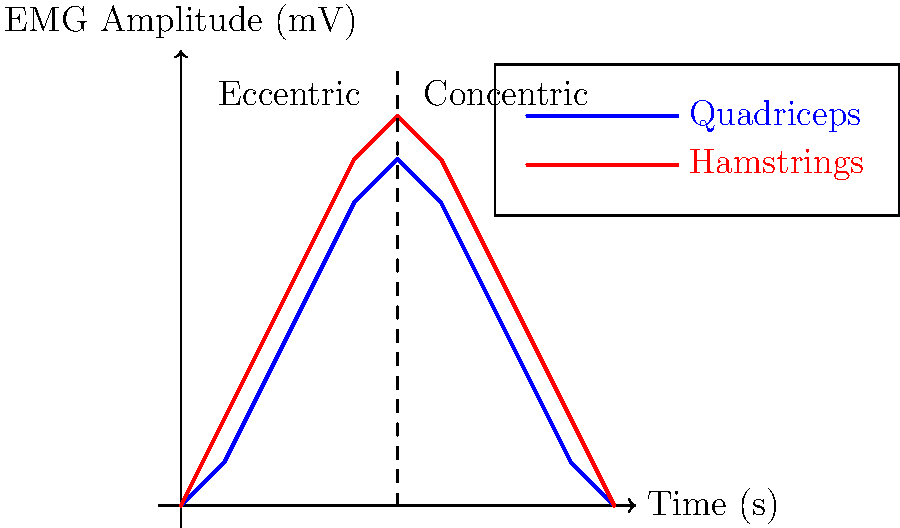Based on the EMG graph showing muscle activation patterns during a squat exercise, which muscle group exhibits higher peak activation, and at what approximate time does this occur? To answer this question, we need to analyze the EMG graph carefully:

1. The graph shows the activation patterns of two muscle groups: Quadriceps (blue line) and Hamstrings (red line).

2. The x-axis represents time in seconds, while the y-axis represents EMG amplitude in millivolts (mV).

3. The squat exercise is divided into two phases: eccentric (lowering) and concentric (rising), separated by a dashed line at 5 seconds.

4. To determine which muscle group has higher peak activation:
   a. Observe the maximum y-value reached by each line.
   b. The red line (Hamstrings) reaches a higher peak than the blue line (Quadriceps).

5. To find the approximate time of peak activation for the Hamstrings:
   a. Locate the highest point on the red line.
   b. This point occurs at approximately 5 seconds on the x-axis.

6. The peak activation of the Hamstrings coincides with the transition point between the eccentric and concentric phases of the squat.

Therefore, the Hamstrings exhibit higher peak activation, occurring at approximately 5 seconds into the exercise.
Answer: Hamstrings, 5 seconds 